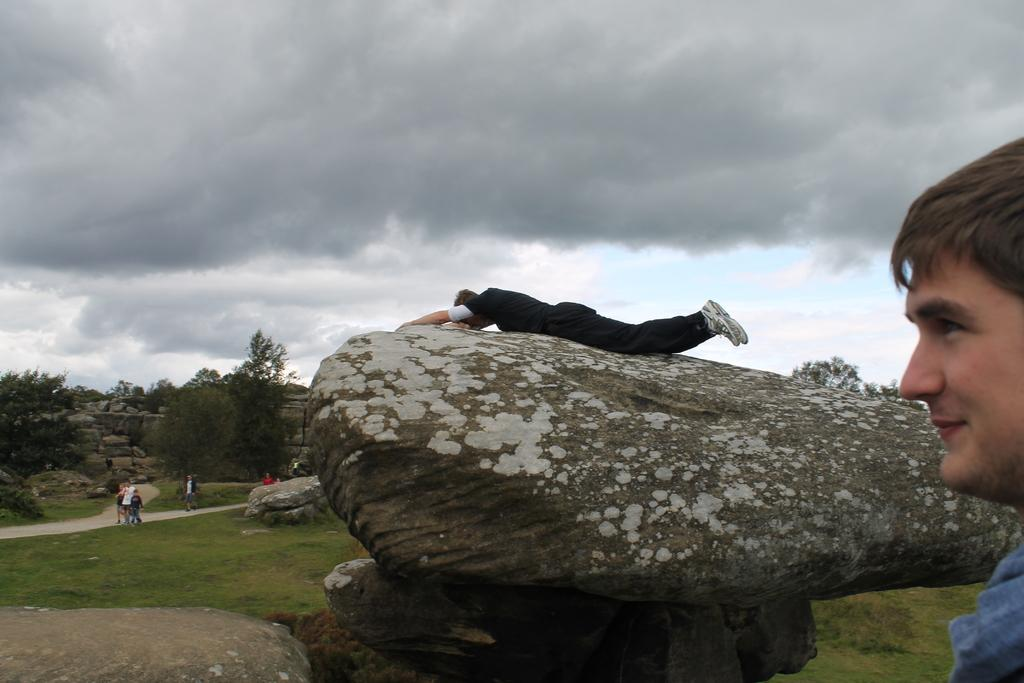What can be seen in the sky in the image? The sky is visible in the image, but no specific details about the sky are mentioned. What type of vegetation is present in the image? There are trees and grass in the image. What are the people in the image doing? There are people walking in the image, and one person is sleeping on a rock. Can you describe the rock in the image? There is a rock in the image, and a person is sleeping on it. Where is the person towards the right side of the image located? The person towards the right side of the image is walking. What is the grandmother doing in the image? There is no mention of a grandmother in the image, so it is not possible to answer this question. 